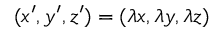Convert formula to latex. <formula><loc_0><loc_0><loc_500><loc_500>( x ^ { \prime } , y ^ { \prime } , z ^ { \prime } ) = ( \lambda x , \lambda y , \lambda z )</formula> 